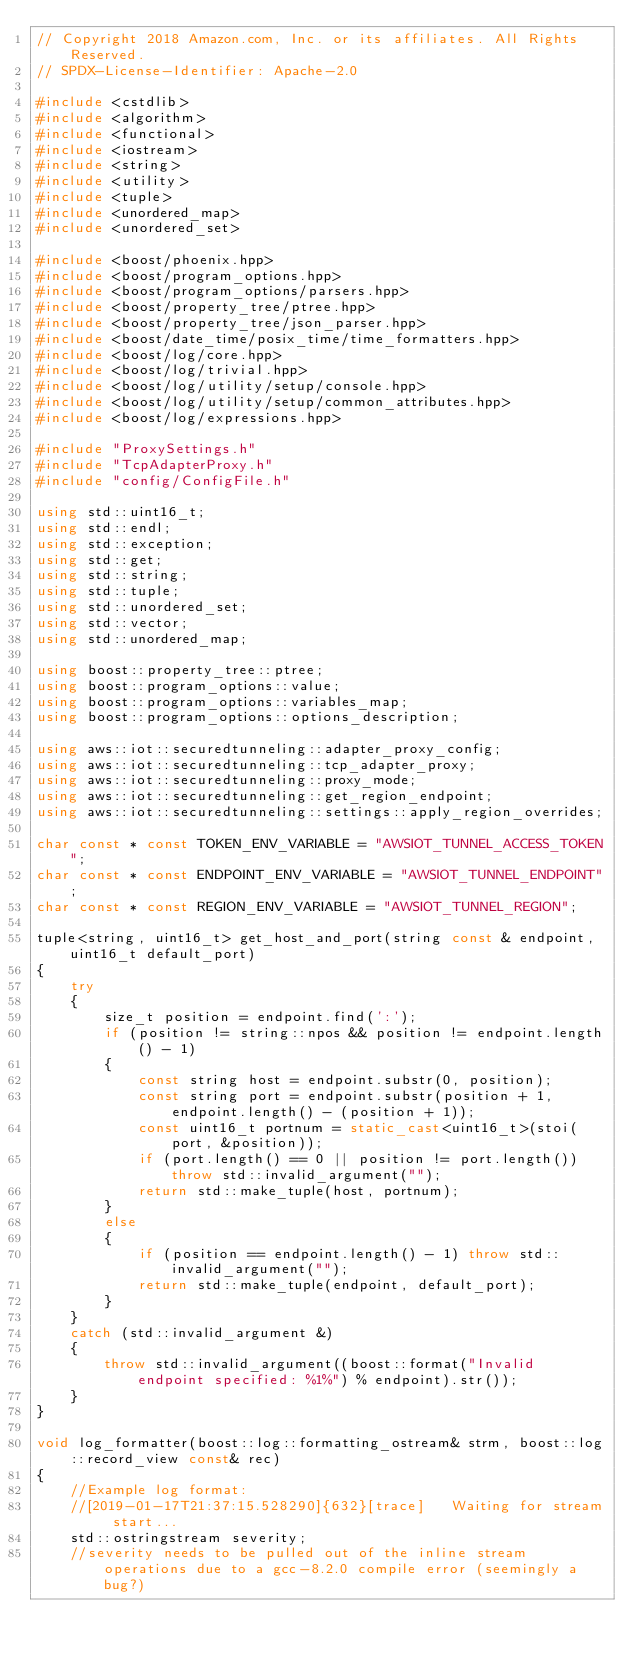Convert code to text. <code><loc_0><loc_0><loc_500><loc_500><_C++_>// Copyright 2018 Amazon.com, Inc. or its affiliates. All Rights Reserved.
// SPDX-License-Identifier: Apache-2.0

#include <cstdlib>
#include <algorithm>
#include <functional>
#include <iostream>
#include <string>
#include <utility>
#include <tuple>
#include <unordered_map>
#include <unordered_set>

#include <boost/phoenix.hpp>
#include <boost/program_options.hpp>
#include <boost/program_options/parsers.hpp>
#include <boost/property_tree/ptree.hpp>
#include <boost/property_tree/json_parser.hpp>
#include <boost/date_time/posix_time/time_formatters.hpp>
#include <boost/log/core.hpp>
#include <boost/log/trivial.hpp>
#include <boost/log/utility/setup/console.hpp>
#include <boost/log/utility/setup/common_attributes.hpp>
#include <boost/log/expressions.hpp>

#include "ProxySettings.h"
#include "TcpAdapterProxy.h"
#include "config/ConfigFile.h"

using std::uint16_t;
using std::endl;
using std::exception;
using std::get;
using std::string;
using std::tuple;
using std::unordered_set;
using std::vector;
using std::unordered_map;

using boost::property_tree::ptree;
using boost::program_options::value;
using boost::program_options::variables_map;
using boost::program_options::options_description;

using aws::iot::securedtunneling::adapter_proxy_config;
using aws::iot::securedtunneling::tcp_adapter_proxy;
using aws::iot::securedtunneling::proxy_mode;
using aws::iot::securedtunneling::get_region_endpoint;
using aws::iot::securedtunneling::settings::apply_region_overrides;

char const * const TOKEN_ENV_VARIABLE = "AWSIOT_TUNNEL_ACCESS_TOKEN";
char const * const ENDPOINT_ENV_VARIABLE = "AWSIOT_TUNNEL_ENDPOINT";
char const * const REGION_ENV_VARIABLE = "AWSIOT_TUNNEL_REGION";

tuple<string, uint16_t> get_host_and_port(string const & endpoint, uint16_t default_port)
{
    try
    {
        size_t position = endpoint.find(':');
        if (position != string::npos && position != endpoint.length() - 1)
        {
            const string host = endpoint.substr(0, position);
            const string port = endpoint.substr(position + 1, endpoint.length() - (position + 1));
            const uint16_t portnum = static_cast<uint16_t>(stoi(port, &position));
            if (port.length() == 0 || position != port.length()) throw std::invalid_argument("");
            return std::make_tuple(host, portnum);
        }
        else
        {
            if (position == endpoint.length() - 1) throw std::invalid_argument("");
            return std::make_tuple(endpoint, default_port);
        }
    }
    catch (std::invalid_argument &)
    {
        throw std::invalid_argument((boost::format("Invalid endpoint specified: %1%") % endpoint).str());
    }
}

void log_formatter(boost::log::formatting_ostream& strm, boost::log::record_view const& rec)
{
    //Example log format:
    //[2019-01-17T21:37:15.528290]{632}[trace]   Waiting for stream start...
    std::ostringstream severity;
    //severity needs to be pulled out of the inline stream operations due to a gcc-8.2.0 compile error (seemingly a bug?)</code> 